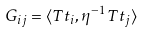<formula> <loc_0><loc_0><loc_500><loc_500>G _ { i j } = \langle T t _ { i } , \eta ^ { - 1 } T t _ { j } \rangle</formula> 